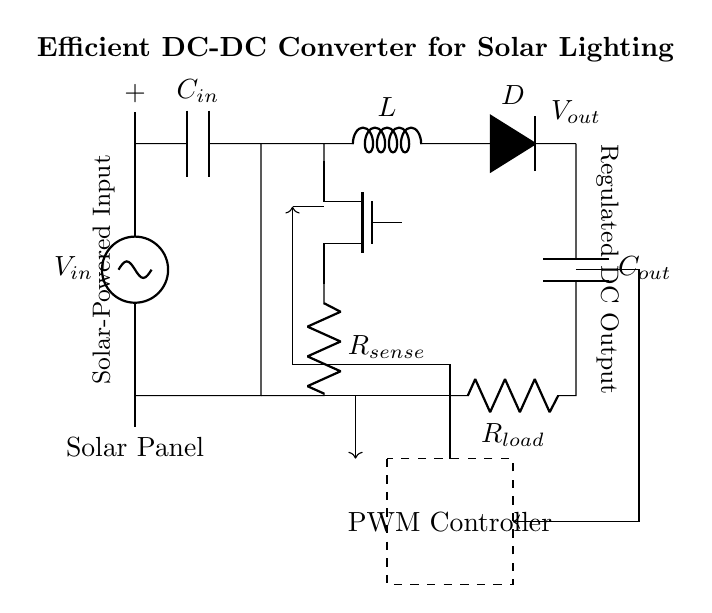What is the input component in this circuit? The input component is identified as the solar panel. It is connected to the input voltage and provides energy to the circuit.
Answer: solar panel What type of switch is used in the circuit? The switch used is a MOSFET, specifically a N-channel MOSFET, as denoted in the diagram. It controls the flow of current in the circuit.
Answer: MOSFET What is the purpose of the inductor in this circuit? The inductor is used to store energy temporarily and help in converting the input voltage to a regulated output voltage during the switching process.
Answer: energy storage How many capacitors are present in the circuit? There are two capacitors: one at the input and one at the output, which stabilize the voltage levels before and after the regulator.
Answer: two What does the PWM controller do? The PWM controller regulates the output voltage by adjusting the duty cycle of the switching MOSFET, therefore controlling the energy supplied to the load.
Answer: regulates voltage What is the role of the diode in the circuit? The diode is used to prevent backflow of current, allowing the current to flow in only one direction, which is essential for maintaining proper operation of the DC-DC converter.
Answer: prevent backflow 